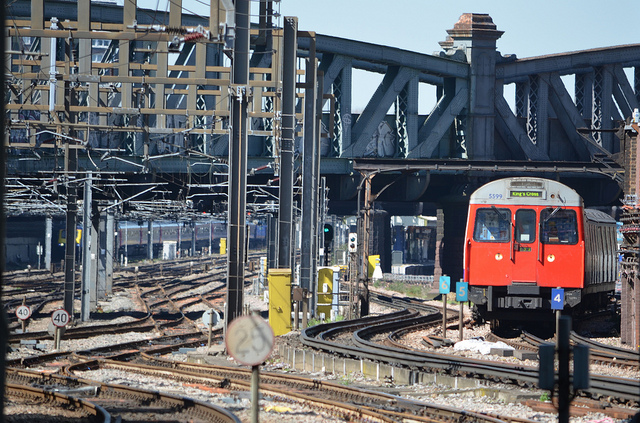Read and extract the text from this image. 4 25 40 